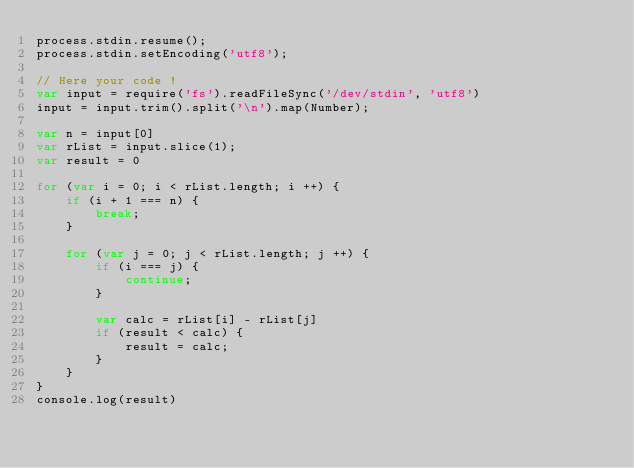Convert code to text. <code><loc_0><loc_0><loc_500><loc_500><_JavaScript_>process.stdin.resume();
process.stdin.setEncoding('utf8');

// Here your code !
var input = require('fs').readFileSync('/dev/stdin', 'utf8')
input = input.trim().split('\n').map(Number);

var n = input[0]
var rList = input.slice(1);
var result = 0

for (var i = 0; i < rList.length; i ++) {
    if (i + 1 === n) {
        break;
    }
    
    for (var j = 0; j < rList.length; j ++) {
        if (i === j) {
            continue;
        }

        var calc = rList[i] - rList[j]
        if (result < calc) {
            result = calc;
        }
    }
}
console.log(result)</code> 